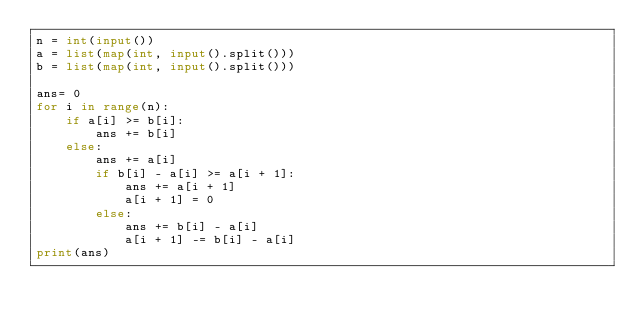<code> <loc_0><loc_0><loc_500><loc_500><_Python_>n = int(input())
a = list(map(int, input().split()))
b = list(map(int, input().split()))

ans= 0
for i in range(n):
    if a[i] >= b[i]:
        ans += b[i]
    else:
        ans += a[i]
        if b[i] - a[i] >= a[i + 1]:
            ans += a[i + 1]
            a[i + 1] = 0
        else:
            ans += b[i] - a[i]
            a[i + 1] -= b[i] - a[i]
print(ans)</code> 